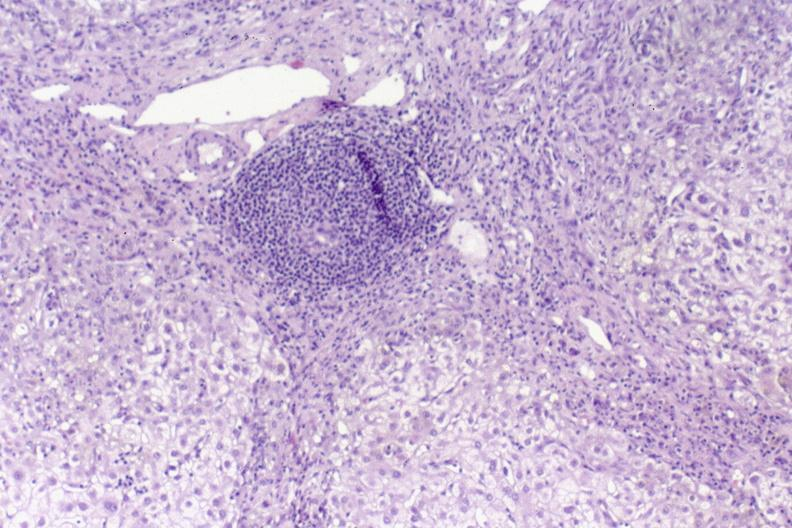does the excellent uterus show primary biliary cirrhosis?
Answer the question using a single word or phrase. No 